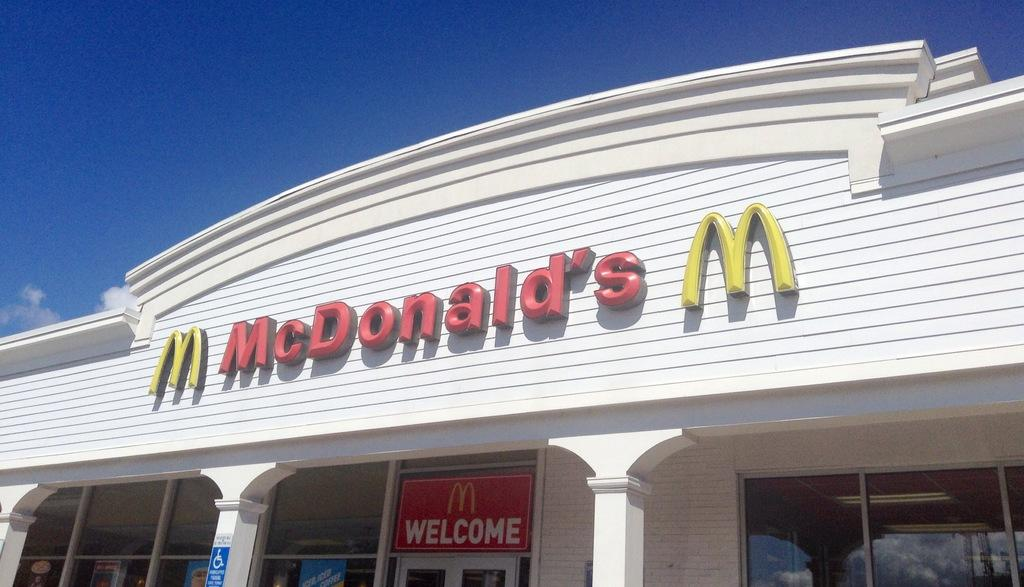What type of structure is present in the image? There is a building in the image. What can be seen on the wall of the building? There is text on the wall of the building. What architectural features are visible in the image? There are pillars in the image. What is located at the bottom of the image? A name board is visible at the bottom of the image. What is visible at the top of the image? The sky is visible at the top of the image. What type of quill is being used to write on the page in the image? There is no quill or page present in the image; it features a building with text on the wall, pillars, a name board, and a visible sky. 